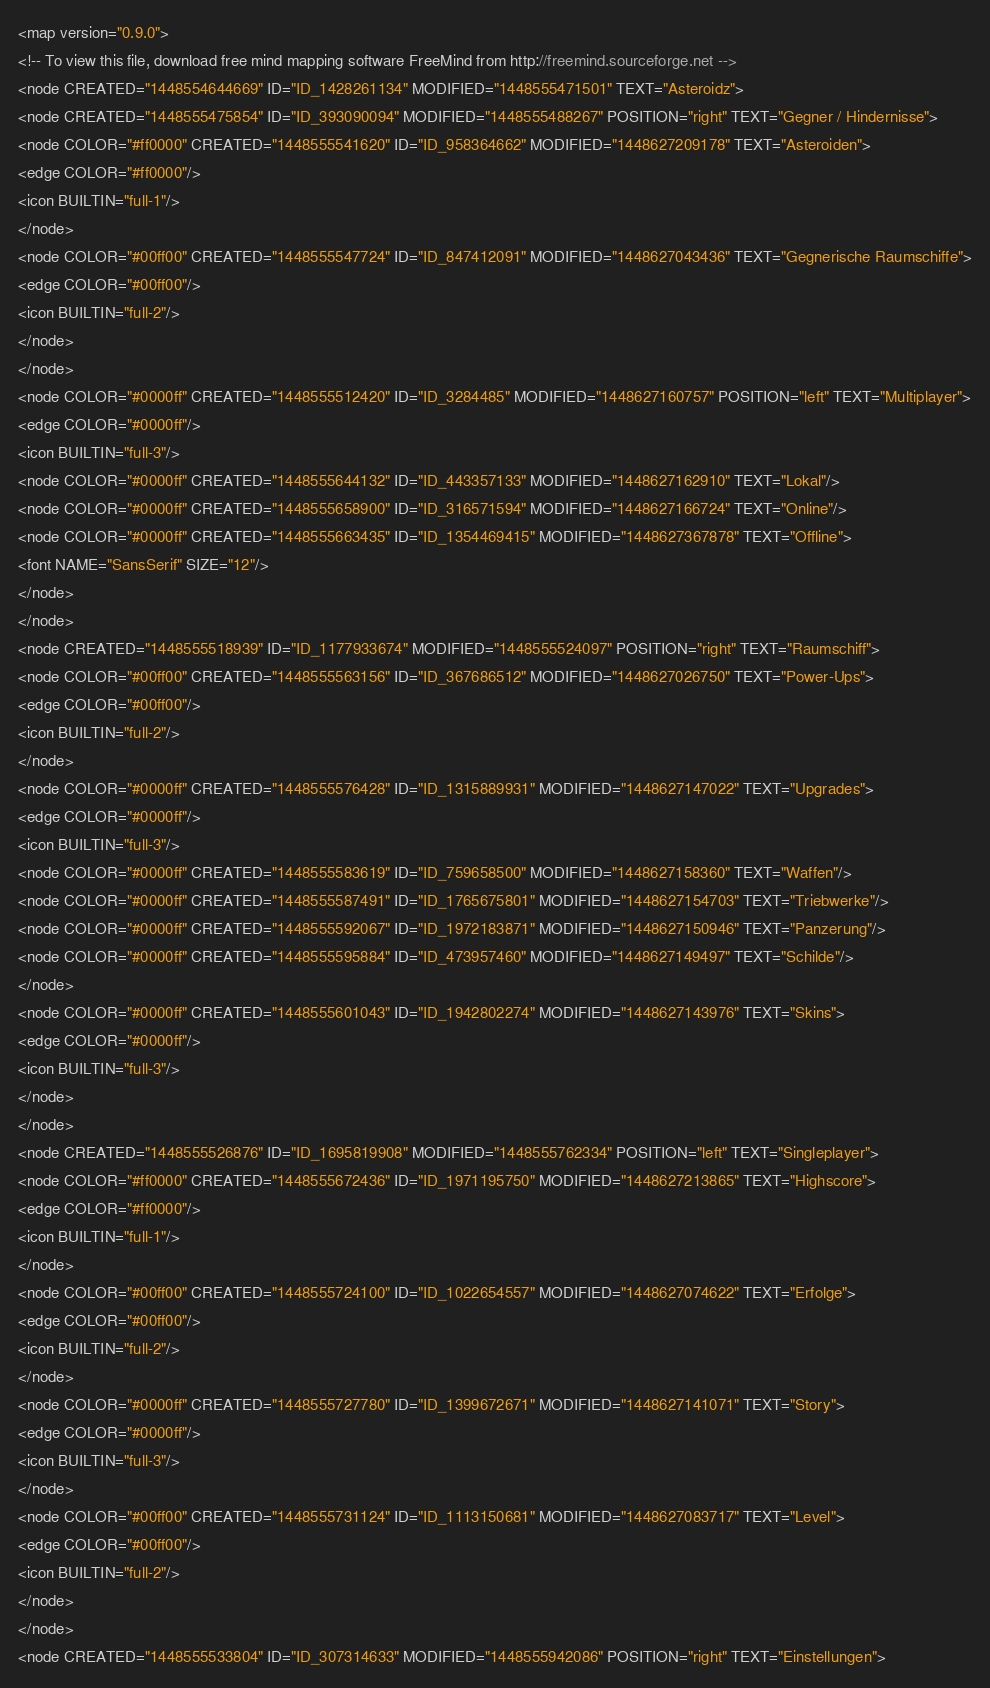Convert code to text. <code><loc_0><loc_0><loc_500><loc_500><_ObjectiveC_><map version="0.9.0">
<!-- To view this file, download free mind mapping software FreeMind from http://freemind.sourceforge.net -->
<node CREATED="1448554644669" ID="ID_1428261134" MODIFIED="1448555471501" TEXT="Asteroidz">
<node CREATED="1448555475854" ID="ID_393090094" MODIFIED="1448555488267" POSITION="right" TEXT="Gegner / Hindernisse">
<node COLOR="#ff0000" CREATED="1448555541620" ID="ID_958364662" MODIFIED="1448627209178" TEXT="Asteroiden">
<edge COLOR="#ff0000"/>
<icon BUILTIN="full-1"/>
</node>
<node COLOR="#00ff00" CREATED="1448555547724" ID="ID_847412091" MODIFIED="1448627043436" TEXT="Gegnerische Raumschiffe">
<edge COLOR="#00ff00"/>
<icon BUILTIN="full-2"/>
</node>
</node>
<node COLOR="#0000ff" CREATED="1448555512420" ID="ID_3284485" MODIFIED="1448627160757" POSITION="left" TEXT="Multiplayer">
<edge COLOR="#0000ff"/>
<icon BUILTIN="full-3"/>
<node COLOR="#0000ff" CREATED="1448555644132" ID="ID_443357133" MODIFIED="1448627162910" TEXT="Lokal"/>
<node COLOR="#0000ff" CREATED="1448555658900" ID="ID_316571594" MODIFIED="1448627166724" TEXT="Online"/>
<node COLOR="#0000ff" CREATED="1448555663435" ID="ID_1354469415" MODIFIED="1448627367878" TEXT="Offline">
<font NAME="SansSerif" SIZE="12"/>
</node>
</node>
<node CREATED="1448555518939" ID="ID_1177933674" MODIFIED="1448555524097" POSITION="right" TEXT="Raumschiff">
<node COLOR="#00ff00" CREATED="1448555563156" ID="ID_367686512" MODIFIED="1448627026750" TEXT="Power-Ups">
<edge COLOR="#00ff00"/>
<icon BUILTIN="full-2"/>
</node>
<node COLOR="#0000ff" CREATED="1448555576428" ID="ID_1315889931" MODIFIED="1448627147022" TEXT="Upgrades">
<edge COLOR="#0000ff"/>
<icon BUILTIN="full-3"/>
<node COLOR="#0000ff" CREATED="1448555583619" ID="ID_759658500" MODIFIED="1448627158360" TEXT="Waffen"/>
<node COLOR="#0000ff" CREATED="1448555587491" ID="ID_1765675801" MODIFIED="1448627154703" TEXT="Triebwerke"/>
<node COLOR="#0000ff" CREATED="1448555592067" ID="ID_1972183871" MODIFIED="1448627150946" TEXT="Panzerung"/>
<node COLOR="#0000ff" CREATED="1448555595884" ID="ID_473957460" MODIFIED="1448627149497" TEXT="Schilde"/>
</node>
<node COLOR="#0000ff" CREATED="1448555601043" ID="ID_1942802274" MODIFIED="1448627143976" TEXT="Skins">
<edge COLOR="#0000ff"/>
<icon BUILTIN="full-3"/>
</node>
</node>
<node CREATED="1448555526876" ID="ID_1695819908" MODIFIED="1448555762334" POSITION="left" TEXT="Singleplayer">
<node COLOR="#ff0000" CREATED="1448555672436" ID="ID_1971195750" MODIFIED="1448627213865" TEXT="Highscore">
<edge COLOR="#ff0000"/>
<icon BUILTIN="full-1"/>
</node>
<node COLOR="#00ff00" CREATED="1448555724100" ID="ID_1022654557" MODIFIED="1448627074622" TEXT="Erfolge">
<edge COLOR="#00ff00"/>
<icon BUILTIN="full-2"/>
</node>
<node COLOR="#0000ff" CREATED="1448555727780" ID="ID_1399672671" MODIFIED="1448627141071" TEXT="Story">
<edge COLOR="#0000ff"/>
<icon BUILTIN="full-3"/>
</node>
<node COLOR="#00ff00" CREATED="1448555731124" ID="ID_1113150681" MODIFIED="1448627083717" TEXT="Level">
<edge COLOR="#00ff00"/>
<icon BUILTIN="full-2"/>
</node>
</node>
<node CREATED="1448555533804" ID="ID_307314633" MODIFIED="1448555942086" POSITION="right" TEXT="Einstellungen"></code> 